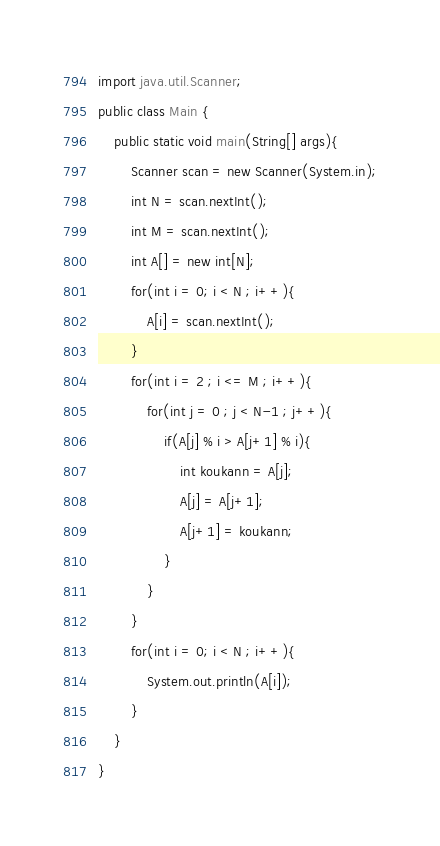Convert code to text. <code><loc_0><loc_0><loc_500><loc_500><_Java_>import java.util.Scanner;
public class Main {
	public static void main(String[] args){
		Scanner scan = new Scanner(System.in);
		int N = scan.nextInt();
		int M = scan.nextInt();
		int A[] = new int[N];
		for(int i = 0; i < N ; i++){
			A[i] = scan.nextInt();
		}
		for(int i = 2 ; i <= M ; i++){
			for(int j = 0 ; j < N-1 ; j++){
				if(A[j] % i > A[j+1] % i){
					int koukann = A[j];
					A[j] = A[j+1];
					A[j+1] = koukann;
				}
			}
		}
		for(int i = 0; i < N ; i++){
			System.out.println(A[i]);
		}
	}
}</code> 